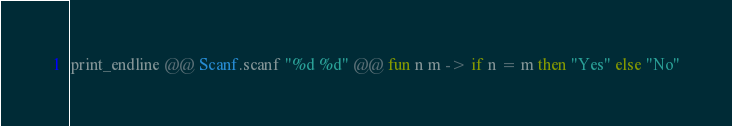<code> <loc_0><loc_0><loc_500><loc_500><_OCaml_>print_endline @@ Scanf.scanf "%d %d" @@ fun n m -> if n = m then "Yes" else "No"
</code> 